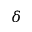<formula> <loc_0><loc_0><loc_500><loc_500>\delta</formula> 